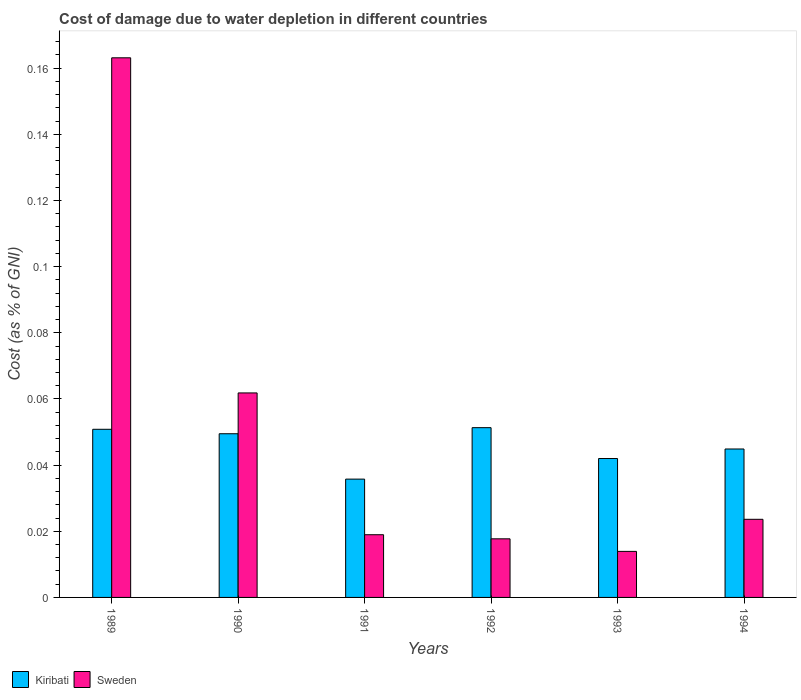How many different coloured bars are there?
Your answer should be very brief. 2. How many groups of bars are there?
Your response must be concise. 6. Are the number of bars per tick equal to the number of legend labels?
Your response must be concise. Yes. How many bars are there on the 1st tick from the right?
Give a very brief answer. 2. What is the label of the 2nd group of bars from the left?
Make the answer very short. 1990. What is the cost of damage caused due to water depletion in Kiribati in 1992?
Your answer should be compact. 0.05. Across all years, what is the maximum cost of damage caused due to water depletion in Kiribati?
Your answer should be compact. 0.05. Across all years, what is the minimum cost of damage caused due to water depletion in Kiribati?
Your answer should be very brief. 0.04. In which year was the cost of damage caused due to water depletion in Kiribati maximum?
Your answer should be very brief. 1992. What is the total cost of damage caused due to water depletion in Sweden in the graph?
Provide a succinct answer. 0.3. What is the difference between the cost of damage caused due to water depletion in Kiribati in 1991 and that in 1992?
Offer a very short reply. -0.02. What is the difference between the cost of damage caused due to water depletion in Kiribati in 1993 and the cost of damage caused due to water depletion in Sweden in 1991?
Your answer should be very brief. 0.02. What is the average cost of damage caused due to water depletion in Sweden per year?
Make the answer very short. 0.05. In the year 1992, what is the difference between the cost of damage caused due to water depletion in Kiribati and cost of damage caused due to water depletion in Sweden?
Provide a short and direct response. 0.03. What is the ratio of the cost of damage caused due to water depletion in Kiribati in 1992 to that in 1993?
Provide a succinct answer. 1.22. Is the difference between the cost of damage caused due to water depletion in Kiribati in 1989 and 1992 greater than the difference between the cost of damage caused due to water depletion in Sweden in 1989 and 1992?
Offer a very short reply. No. What is the difference between the highest and the second highest cost of damage caused due to water depletion in Sweden?
Provide a short and direct response. 0.1. What is the difference between the highest and the lowest cost of damage caused due to water depletion in Sweden?
Offer a very short reply. 0.15. What does the 1st bar from the left in 1993 represents?
Make the answer very short. Kiribati. What does the 1st bar from the right in 1990 represents?
Offer a very short reply. Sweden. How many bars are there?
Offer a terse response. 12. How many years are there in the graph?
Offer a very short reply. 6. Are the values on the major ticks of Y-axis written in scientific E-notation?
Ensure brevity in your answer.  No. Does the graph contain any zero values?
Provide a succinct answer. No. Does the graph contain grids?
Ensure brevity in your answer.  No. How many legend labels are there?
Offer a terse response. 2. What is the title of the graph?
Make the answer very short. Cost of damage due to water depletion in different countries. Does "Benin" appear as one of the legend labels in the graph?
Provide a succinct answer. No. What is the label or title of the X-axis?
Give a very brief answer. Years. What is the label or title of the Y-axis?
Offer a very short reply. Cost (as % of GNI). What is the Cost (as % of GNI) of Kiribati in 1989?
Your answer should be compact. 0.05. What is the Cost (as % of GNI) in Sweden in 1989?
Make the answer very short. 0.16. What is the Cost (as % of GNI) of Kiribati in 1990?
Keep it short and to the point. 0.05. What is the Cost (as % of GNI) of Sweden in 1990?
Provide a short and direct response. 0.06. What is the Cost (as % of GNI) in Kiribati in 1991?
Make the answer very short. 0.04. What is the Cost (as % of GNI) in Sweden in 1991?
Keep it short and to the point. 0.02. What is the Cost (as % of GNI) of Kiribati in 1992?
Ensure brevity in your answer.  0.05. What is the Cost (as % of GNI) in Sweden in 1992?
Provide a succinct answer. 0.02. What is the Cost (as % of GNI) of Kiribati in 1993?
Keep it short and to the point. 0.04. What is the Cost (as % of GNI) in Sweden in 1993?
Provide a succinct answer. 0.01. What is the Cost (as % of GNI) in Kiribati in 1994?
Your answer should be compact. 0.04. What is the Cost (as % of GNI) in Sweden in 1994?
Offer a terse response. 0.02. Across all years, what is the maximum Cost (as % of GNI) of Kiribati?
Give a very brief answer. 0.05. Across all years, what is the maximum Cost (as % of GNI) in Sweden?
Ensure brevity in your answer.  0.16. Across all years, what is the minimum Cost (as % of GNI) in Kiribati?
Offer a very short reply. 0.04. Across all years, what is the minimum Cost (as % of GNI) in Sweden?
Your response must be concise. 0.01. What is the total Cost (as % of GNI) of Kiribati in the graph?
Provide a short and direct response. 0.27. What is the total Cost (as % of GNI) in Sweden in the graph?
Make the answer very short. 0.3. What is the difference between the Cost (as % of GNI) in Kiribati in 1989 and that in 1990?
Your answer should be compact. 0. What is the difference between the Cost (as % of GNI) of Sweden in 1989 and that in 1990?
Offer a terse response. 0.1. What is the difference between the Cost (as % of GNI) in Kiribati in 1989 and that in 1991?
Provide a succinct answer. 0.02. What is the difference between the Cost (as % of GNI) in Sweden in 1989 and that in 1991?
Offer a very short reply. 0.14. What is the difference between the Cost (as % of GNI) of Kiribati in 1989 and that in 1992?
Make the answer very short. -0. What is the difference between the Cost (as % of GNI) of Sweden in 1989 and that in 1992?
Provide a succinct answer. 0.15. What is the difference between the Cost (as % of GNI) of Kiribati in 1989 and that in 1993?
Your response must be concise. 0.01. What is the difference between the Cost (as % of GNI) of Sweden in 1989 and that in 1993?
Offer a very short reply. 0.15. What is the difference between the Cost (as % of GNI) in Kiribati in 1989 and that in 1994?
Give a very brief answer. 0.01. What is the difference between the Cost (as % of GNI) of Sweden in 1989 and that in 1994?
Offer a very short reply. 0.14. What is the difference between the Cost (as % of GNI) in Kiribati in 1990 and that in 1991?
Give a very brief answer. 0.01. What is the difference between the Cost (as % of GNI) in Sweden in 1990 and that in 1991?
Give a very brief answer. 0.04. What is the difference between the Cost (as % of GNI) in Kiribati in 1990 and that in 1992?
Provide a short and direct response. -0. What is the difference between the Cost (as % of GNI) in Sweden in 1990 and that in 1992?
Make the answer very short. 0.04. What is the difference between the Cost (as % of GNI) of Kiribati in 1990 and that in 1993?
Offer a terse response. 0.01. What is the difference between the Cost (as % of GNI) in Sweden in 1990 and that in 1993?
Keep it short and to the point. 0.05. What is the difference between the Cost (as % of GNI) of Kiribati in 1990 and that in 1994?
Your response must be concise. 0. What is the difference between the Cost (as % of GNI) of Sweden in 1990 and that in 1994?
Provide a succinct answer. 0.04. What is the difference between the Cost (as % of GNI) in Kiribati in 1991 and that in 1992?
Keep it short and to the point. -0.02. What is the difference between the Cost (as % of GNI) in Sweden in 1991 and that in 1992?
Make the answer very short. 0. What is the difference between the Cost (as % of GNI) of Kiribati in 1991 and that in 1993?
Make the answer very short. -0.01. What is the difference between the Cost (as % of GNI) of Sweden in 1991 and that in 1993?
Make the answer very short. 0.01. What is the difference between the Cost (as % of GNI) in Kiribati in 1991 and that in 1994?
Your response must be concise. -0.01. What is the difference between the Cost (as % of GNI) of Sweden in 1991 and that in 1994?
Your response must be concise. -0. What is the difference between the Cost (as % of GNI) in Kiribati in 1992 and that in 1993?
Your answer should be compact. 0.01. What is the difference between the Cost (as % of GNI) in Sweden in 1992 and that in 1993?
Provide a succinct answer. 0. What is the difference between the Cost (as % of GNI) of Kiribati in 1992 and that in 1994?
Give a very brief answer. 0.01. What is the difference between the Cost (as % of GNI) of Sweden in 1992 and that in 1994?
Provide a succinct answer. -0.01. What is the difference between the Cost (as % of GNI) in Kiribati in 1993 and that in 1994?
Your answer should be very brief. -0. What is the difference between the Cost (as % of GNI) in Sweden in 1993 and that in 1994?
Your answer should be very brief. -0.01. What is the difference between the Cost (as % of GNI) in Kiribati in 1989 and the Cost (as % of GNI) in Sweden in 1990?
Provide a succinct answer. -0.01. What is the difference between the Cost (as % of GNI) of Kiribati in 1989 and the Cost (as % of GNI) of Sweden in 1991?
Ensure brevity in your answer.  0.03. What is the difference between the Cost (as % of GNI) of Kiribati in 1989 and the Cost (as % of GNI) of Sweden in 1992?
Ensure brevity in your answer.  0.03. What is the difference between the Cost (as % of GNI) in Kiribati in 1989 and the Cost (as % of GNI) in Sweden in 1993?
Offer a very short reply. 0.04. What is the difference between the Cost (as % of GNI) in Kiribati in 1989 and the Cost (as % of GNI) in Sweden in 1994?
Keep it short and to the point. 0.03. What is the difference between the Cost (as % of GNI) in Kiribati in 1990 and the Cost (as % of GNI) in Sweden in 1991?
Give a very brief answer. 0.03. What is the difference between the Cost (as % of GNI) in Kiribati in 1990 and the Cost (as % of GNI) in Sweden in 1992?
Ensure brevity in your answer.  0.03. What is the difference between the Cost (as % of GNI) of Kiribati in 1990 and the Cost (as % of GNI) of Sweden in 1993?
Keep it short and to the point. 0.04. What is the difference between the Cost (as % of GNI) in Kiribati in 1990 and the Cost (as % of GNI) in Sweden in 1994?
Provide a succinct answer. 0.03. What is the difference between the Cost (as % of GNI) in Kiribati in 1991 and the Cost (as % of GNI) in Sweden in 1992?
Your answer should be compact. 0.02. What is the difference between the Cost (as % of GNI) of Kiribati in 1991 and the Cost (as % of GNI) of Sweden in 1993?
Give a very brief answer. 0.02. What is the difference between the Cost (as % of GNI) in Kiribati in 1991 and the Cost (as % of GNI) in Sweden in 1994?
Offer a very short reply. 0.01. What is the difference between the Cost (as % of GNI) of Kiribati in 1992 and the Cost (as % of GNI) of Sweden in 1993?
Your response must be concise. 0.04. What is the difference between the Cost (as % of GNI) in Kiribati in 1992 and the Cost (as % of GNI) in Sweden in 1994?
Provide a short and direct response. 0.03. What is the difference between the Cost (as % of GNI) of Kiribati in 1993 and the Cost (as % of GNI) of Sweden in 1994?
Ensure brevity in your answer.  0.02. What is the average Cost (as % of GNI) in Kiribati per year?
Give a very brief answer. 0.05. What is the average Cost (as % of GNI) of Sweden per year?
Offer a very short reply. 0.05. In the year 1989, what is the difference between the Cost (as % of GNI) of Kiribati and Cost (as % of GNI) of Sweden?
Provide a succinct answer. -0.11. In the year 1990, what is the difference between the Cost (as % of GNI) in Kiribati and Cost (as % of GNI) in Sweden?
Keep it short and to the point. -0.01. In the year 1991, what is the difference between the Cost (as % of GNI) of Kiribati and Cost (as % of GNI) of Sweden?
Your response must be concise. 0.02. In the year 1992, what is the difference between the Cost (as % of GNI) in Kiribati and Cost (as % of GNI) in Sweden?
Provide a short and direct response. 0.03. In the year 1993, what is the difference between the Cost (as % of GNI) of Kiribati and Cost (as % of GNI) of Sweden?
Provide a short and direct response. 0.03. In the year 1994, what is the difference between the Cost (as % of GNI) in Kiribati and Cost (as % of GNI) in Sweden?
Your answer should be compact. 0.02. What is the ratio of the Cost (as % of GNI) of Kiribati in 1989 to that in 1990?
Keep it short and to the point. 1.03. What is the ratio of the Cost (as % of GNI) in Sweden in 1989 to that in 1990?
Offer a very short reply. 2.64. What is the ratio of the Cost (as % of GNI) in Kiribati in 1989 to that in 1991?
Ensure brevity in your answer.  1.42. What is the ratio of the Cost (as % of GNI) in Sweden in 1989 to that in 1991?
Keep it short and to the point. 8.61. What is the ratio of the Cost (as % of GNI) in Kiribati in 1989 to that in 1992?
Provide a succinct answer. 0.99. What is the ratio of the Cost (as % of GNI) in Sweden in 1989 to that in 1992?
Provide a succinct answer. 9.21. What is the ratio of the Cost (as % of GNI) in Kiribati in 1989 to that in 1993?
Offer a very short reply. 1.21. What is the ratio of the Cost (as % of GNI) of Sweden in 1989 to that in 1993?
Your answer should be compact. 11.72. What is the ratio of the Cost (as % of GNI) in Kiribati in 1989 to that in 1994?
Your response must be concise. 1.13. What is the ratio of the Cost (as % of GNI) of Sweden in 1989 to that in 1994?
Make the answer very short. 6.91. What is the ratio of the Cost (as % of GNI) in Kiribati in 1990 to that in 1991?
Ensure brevity in your answer.  1.38. What is the ratio of the Cost (as % of GNI) of Sweden in 1990 to that in 1991?
Your response must be concise. 3.26. What is the ratio of the Cost (as % of GNI) of Kiribati in 1990 to that in 1992?
Provide a short and direct response. 0.96. What is the ratio of the Cost (as % of GNI) in Sweden in 1990 to that in 1992?
Provide a short and direct response. 3.49. What is the ratio of the Cost (as % of GNI) of Kiribati in 1990 to that in 1993?
Provide a succinct answer. 1.18. What is the ratio of the Cost (as % of GNI) of Sweden in 1990 to that in 1993?
Offer a very short reply. 4.44. What is the ratio of the Cost (as % of GNI) of Kiribati in 1990 to that in 1994?
Your answer should be very brief. 1.1. What is the ratio of the Cost (as % of GNI) in Sweden in 1990 to that in 1994?
Give a very brief answer. 2.62. What is the ratio of the Cost (as % of GNI) in Kiribati in 1991 to that in 1992?
Keep it short and to the point. 0.7. What is the ratio of the Cost (as % of GNI) in Sweden in 1991 to that in 1992?
Your answer should be very brief. 1.07. What is the ratio of the Cost (as % of GNI) in Kiribati in 1991 to that in 1993?
Your answer should be very brief. 0.85. What is the ratio of the Cost (as % of GNI) in Sweden in 1991 to that in 1993?
Your answer should be compact. 1.36. What is the ratio of the Cost (as % of GNI) in Kiribati in 1991 to that in 1994?
Offer a very short reply. 0.8. What is the ratio of the Cost (as % of GNI) of Sweden in 1991 to that in 1994?
Give a very brief answer. 0.8. What is the ratio of the Cost (as % of GNI) of Kiribati in 1992 to that in 1993?
Provide a succinct answer. 1.22. What is the ratio of the Cost (as % of GNI) in Sweden in 1992 to that in 1993?
Keep it short and to the point. 1.27. What is the ratio of the Cost (as % of GNI) of Kiribati in 1992 to that in 1994?
Your response must be concise. 1.14. What is the ratio of the Cost (as % of GNI) of Sweden in 1992 to that in 1994?
Your answer should be compact. 0.75. What is the ratio of the Cost (as % of GNI) in Kiribati in 1993 to that in 1994?
Your answer should be very brief. 0.94. What is the ratio of the Cost (as % of GNI) in Sweden in 1993 to that in 1994?
Ensure brevity in your answer.  0.59. What is the difference between the highest and the second highest Cost (as % of GNI) in Kiribati?
Offer a very short reply. 0. What is the difference between the highest and the second highest Cost (as % of GNI) in Sweden?
Offer a very short reply. 0.1. What is the difference between the highest and the lowest Cost (as % of GNI) of Kiribati?
Your answer should be very brief. 0.02. What is the difference between the highest and the lowest Cost (as % of GNI) of Sweden?
Provide a succinct answer. 0.15. 